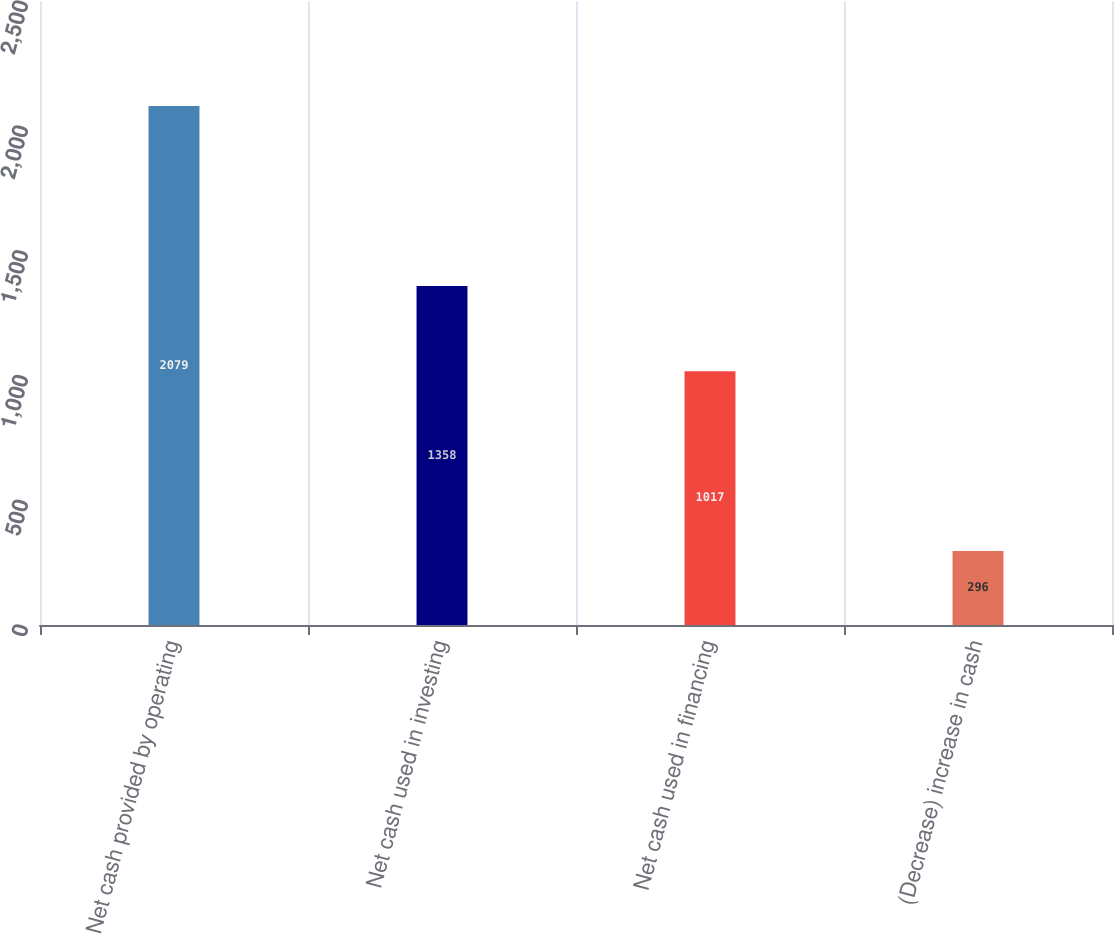Convert chart to OTSL. <chart><loc_0><loc_0><loc_500><loc_500><bar_chart><fcel>Net cash provided by operating<fcel>Net cash used in investing<fcel>Net cash used in financing<fcel>(Decrease) increase in cash<nl><fcel>2079<fcel>1358<fcel>1017<fcel>296<nl></chart> 